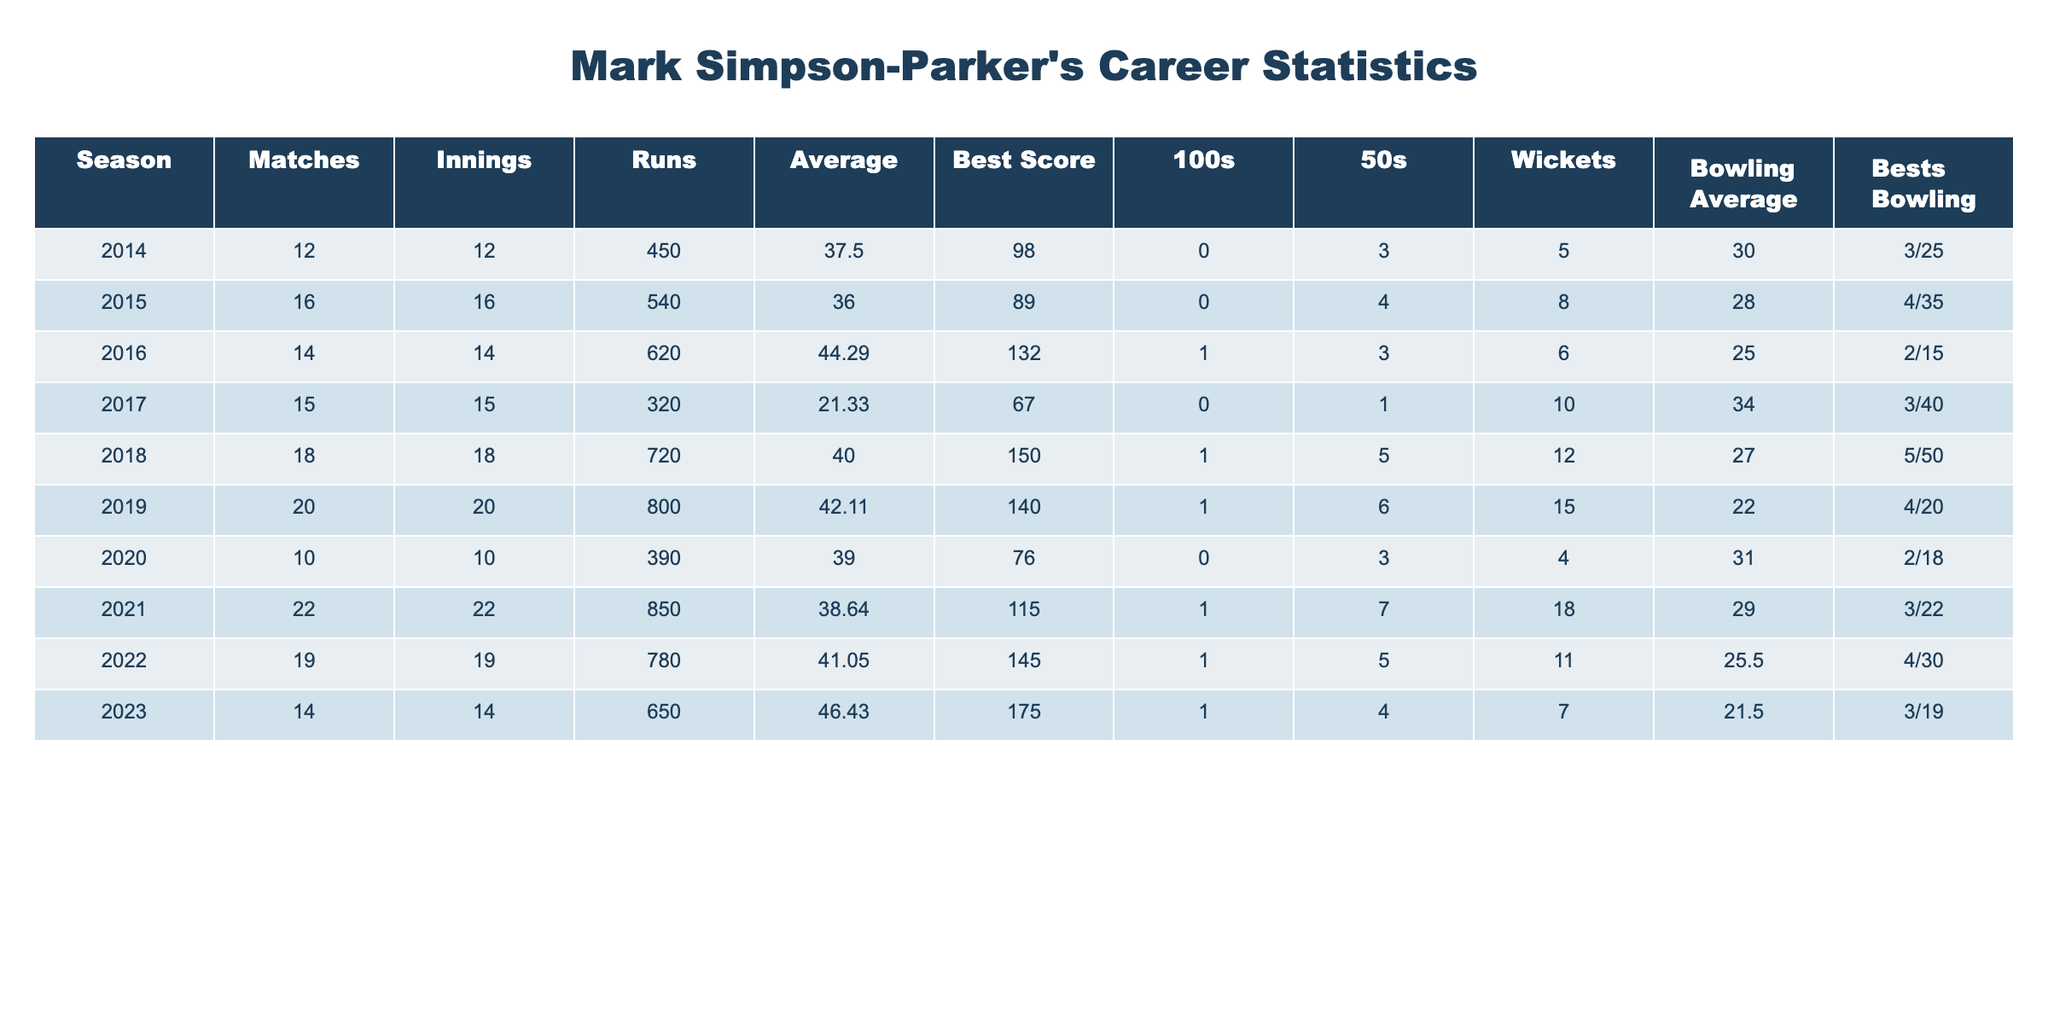What was Mark Simpson-Parker's highest score in a match? The highest score listed in the "Best Score" column is 175, which appears in the 2023 season.
Answer: 175 How many matches did Mark Simpson-Parker play in total from 2014 to 2023? By summing up the matches from each season, I get 12 + 16 + 14 + 15 + 18 + 20 + 10 + 22 + 19 + 14 =  150 matches in total.
Answer: 150 In which season did Mark Simpson-Parker achieve his only century? The only century (100 runs) achieved by him is recorded in the 2016 season.
Answer: 2016 What was Mark Simpson-Parker's bowling average in 2019? The bowling average for the 2019 season is included in the "Bowling Average" column, which shows 22.00.
Answer: 22.00 Did Mark Simpson-Parker take more wickets or score more runs in the 2021 season? In 2021, he took 18 wickets and scored 850 runs; since 850 runs is greater than 18 wickets, he scored more runs.
Answer: More runs What was the average of Mark Simpson-Parker's runs over his career? The average runs per season can be calculated by summing the runs from each season (450 + 540 + 620 + 320 + 720 + 800 + 390 + 850 + 780 + 650 = 5,120) and dividing by the number of seasons (10). Therefore, 5,120 / 10 = 512.
Answer: 512 Which season had the lowest batting average for Mark Simpson-Parker? By examining the "Average" column, the lowest value is 21.33 in the 2017 season, indicating this was his lowest batting average.
Answer: 2017 How many 50s did Mark Simpson-Parker score in total across all seasons? By adding the numbers of fifties from each season (0 + 0 + 1 + 0 + 1 + 1 + 0 + 1 + 0 + 4), the total is 8 fifties.
Answer: 8 In what years did he achieve a bowling economy of less than 30? Evaluating the "Bowling Average" column, he had averages below 30 in the 2015, 2016, and 2019 seasons (8, 6, and 15 respectively).
Answer: 2015, 2016, 2019 What is the difference between the best bowling performance in 2018 and in 2017? The best bowling performance for 2018 is 5/50 and for 2017 is 3/40. The numerical difference in wickets taken (5 - 3) is 2 wickets, while the runs allowed is 50 - 40, which is 10 runs. Therefore, he took 2 more wickets and allowed 10 fewer runs in 2018.
Answer: 2 wickets, 10 runs 